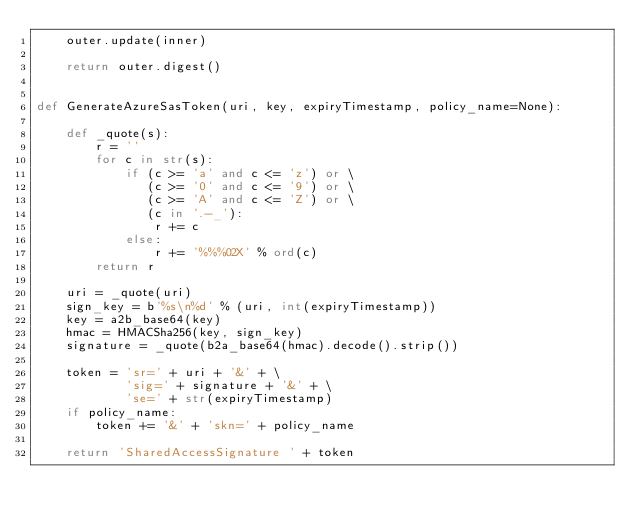<code> <loc_0><loc_0><loc_500><loc_500><_Python_>    outer.update(inner)

    return outer.digest()


def GenerateAzureSasToken(uri, key, expiryTimestamp, policy_name=None):

    def _quote(s):
        r = ''
        for c in str(s):
            if (c >= 'a' and c <= 'z') or \
               (c >= '0' and c <= '9') or \
               (c >= 'A' and c <= 'Z') or \
               (c in '.-_'):
                r += c
            else:
                r += '%%%02X' % ord(c)
        return r

    uri = _quote(uri)
    sign_key = b'%s\n%d' % (uri, int(expiryTimestamp))
    key = a2b_base64(key)
    hmac = HMACSha256(key, sign_key)
    signature = _quote(b2a_base64(hmac).decode().strip())

    token = 'sr=' + uri + '&' + \
            'sig=' + signature + '&' + \
            'se=' + str(expiryTimestamp)
    if policy_name:
        token += '&' + 'skn=' + policy_name

    return 'SharedAccessSignature ' + token
</code> 